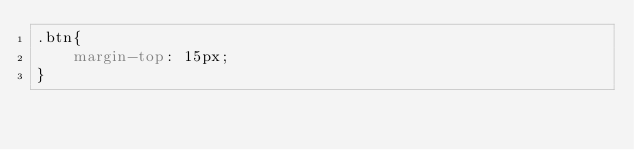<code> <loc_0><loc_0><loc_500><loc_500><_CSS_>.btn{
    margin-top: 15px;
}</code> 